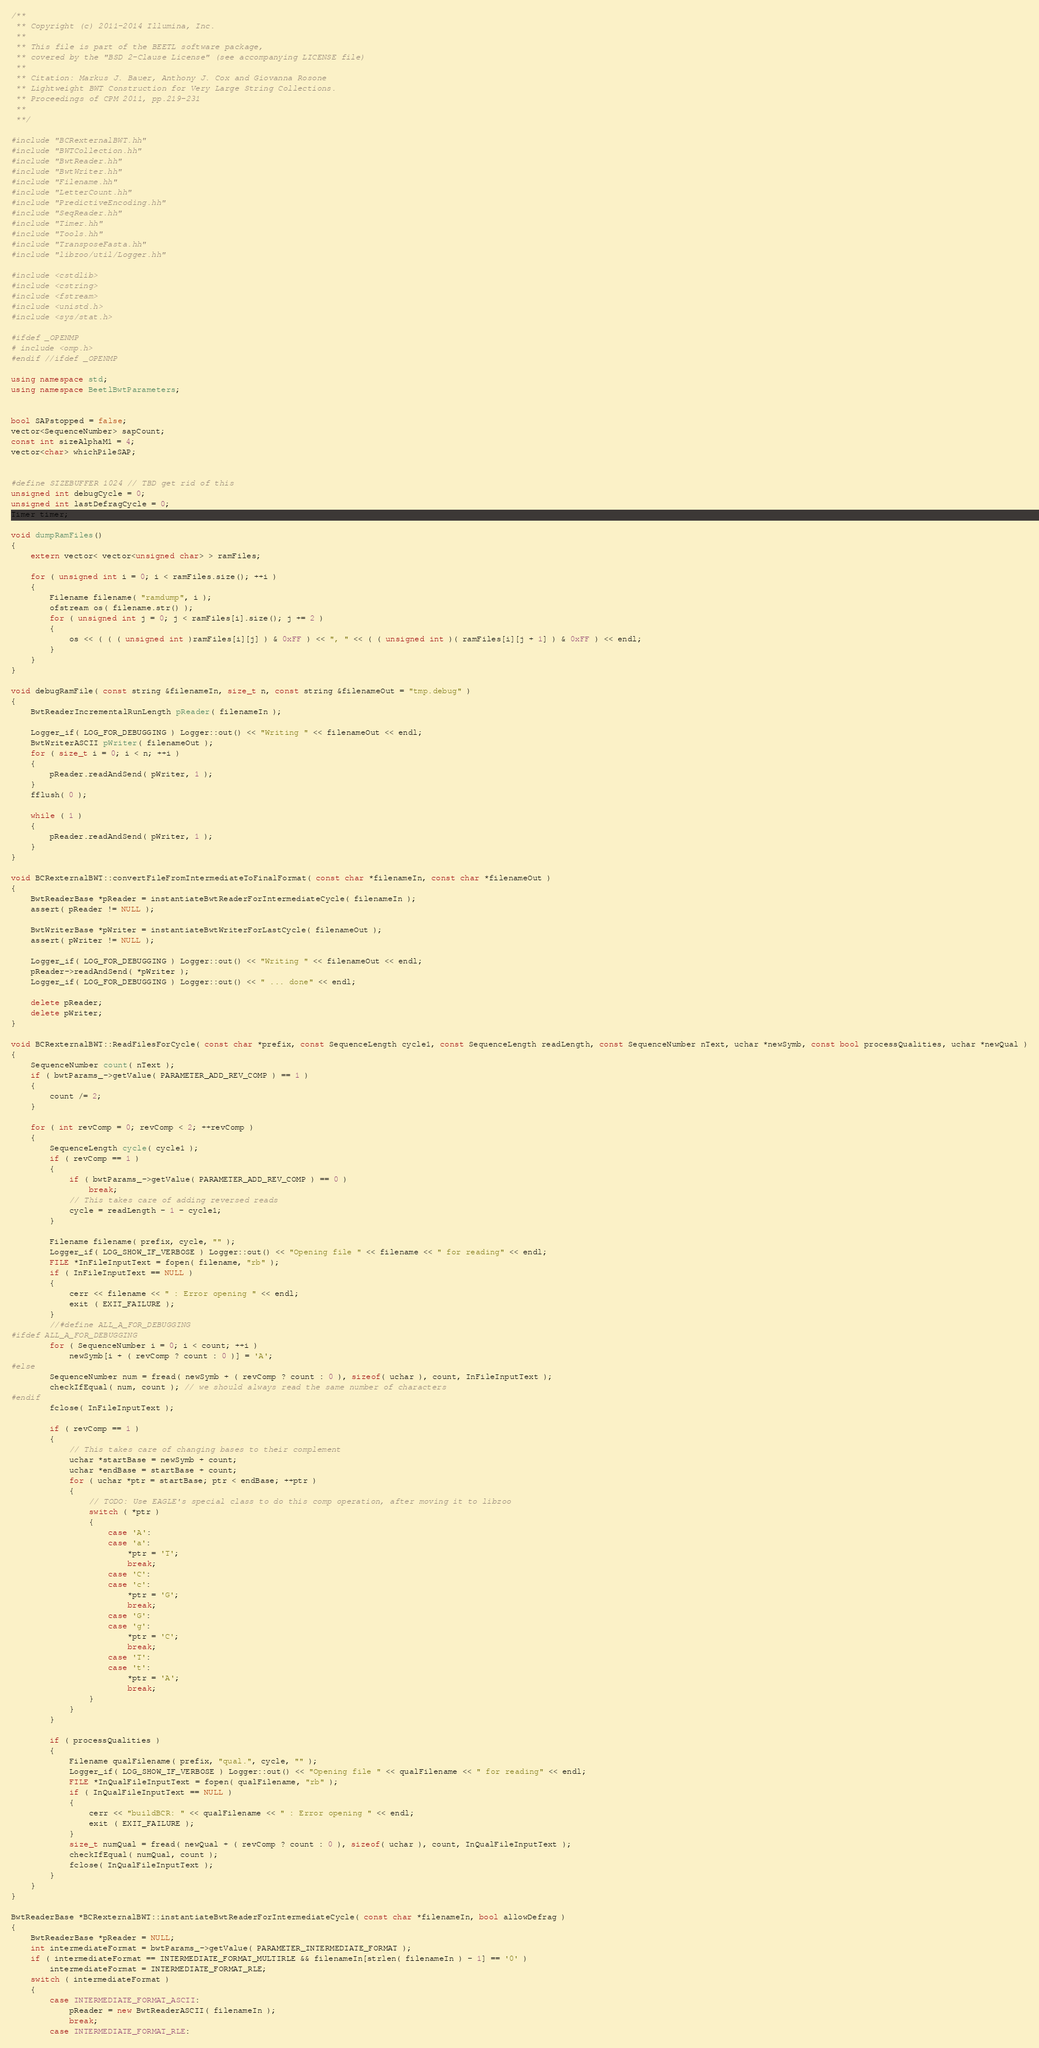Convert code to text. <code><loc_0><loc_0><loc_500><loc_500><_C++_>/**
 ** Copyright (c) 2011-2014 Illumina, Inc.
 **
 ** This file is part of the BEETL software package,
 ** covered by the "BSD 2-Clause License" (see accompanying LICENSE file)
 **
 ** Citation: Markus J. Bauer, Anthony J. Cox and Giovanna Rosone
 ** Lightweight BWT Construction for Very Large String Collections.
 ** Proceedings of CPM 2011, pp.219-231
 **
 **/

#include "BCRexternalBWT.hh"
#include "BWTCollection.hh"
#include "BwtReader.hh"
#include "BwtWriter.hh"
#include "Filename.hh"
#include "LetterCount.hh"
#include "PredictiveEncoding.hh"
#include "SeqReader.hh"
#include "Timer.hh"
#include "Tools.hh"
#include "TransposeFasta.hh"
#include "libzoo/util/Logger.hh"

#include <cstdlib>
#include <cstring>
#include <fstream>
#include <unistd.h>
#include <sys/stat.h>

#ifdef _OPENMP
# include <omp.h>
#endif //ifdef _OPENMP

using namespace std;
using namespace BeetlBwtParameters;


bool SAPstopped = false;
vector<SequenceNumber> sapCount;
const int sizeAlphaM1 = 4;
vector<char> whichPileSAP;


#define SIZEBUFFER 1024 // TBD get rid of this
unsigned int debugCycle = 0;
unsigned int lastDefragCycle = 0;
Timer timer;

void dumpRamFiles()
{
    extern vector< vector<unsigned char> > ramFiles;

    for ( unsigned int i = 0; i < ramFiles.size(); ++i )
    {
        Filename filename( "ramdump", i );
        ofstream os( filename.str() );
        for ( unsigned int j = 0; j < ramFiles[i].size(); j += 2 )
        {
            os << ( ( ( unsigned int )ramFiles[i][j] ) & 0xFF ) << ", " << ( ( unsigned int )( ramFiles[i][j + 1] ) & 0xFF ) << endl;
        }
    }
}

void debugRamFile( const string &filenameIn, size_t n, const string &filenameOut = "tmp.debug" )
{
    BwtReaderIncrementalRunLength pReader( filenameIn );

    Logger_if( LOG_FOR_DEBUGGING ) Logger::out() << "Writing " << filenameOut << endl;
    BwtWriterASCII pWriter( filenameOut );
    for ( size_t i = 0; i < n; ++i )
    {
        pReader.readAndSend( pWriter, 1 );
    }
    fflush( 0 );

    while ( 1 )
    {
        pReader.readAndSend( pWriter, 1 );
    }
}

void BCRexternalBWT::convertFileFromIntermediateToFinalFormat( const char *filenameIn, const char *filenameOut )
{
    BwtReaderBase *pReader = instantiateBwtReaderForIntermediateCycle( filenameIn );
    assert( pReader != NULL );

    BwtWriterBase *pWriter = instantiateBwtWriterForLastCycle( filenameOut );
    assert( pWriter != NULL );

    Logger_if( LOG_FOR_DEBUGGING ) Logger::out() << "Writing " << filenameOut << endl;
    pReader->readAndSend( *pWriter );
    Logger_if( LOG_FOR_DEBUGGING ) Logger::out() << " ... done" << endl;

    delete pReader;
    delete pWriter;
}

void BCRexternalBWT::ReadFilesForCycle( const char *prefix, const SequenceLength cycle1, const SequenceLength readLength, const SequenceNumber nText, uchar *newSymb, const bool processQualities, uchar *newQual )
{
    SequenceNumber count( nText );
    if ( bwtParams_->getValue( PARAMETER_ADD_REV_COMP ) == 1 )
    {
        count /= 2;
    }

    for ( int revComp = 0; revComp < 2; ++revComp )
    {
        SequenceLength cycle( cycle1 );
        if ( revComp == 1 )
        {
            if ( bwtParams_->getValue( PARAMETER_ADD_REV_COMP ) == 0 )
                break;
            // This takes care of adding reversed reads
            cycle = readLength - 1 - cycle1;
        }

        Filename filename( prefix, cycle, "" );
        Logger_if( LOG_SHOW_IF_VERBOSE ) Logger::out() << "Opening file " << filename << " for reading" << endl;
        FILE *InFileInputText = fopen( filename, "rb" );
        if ( InFileInputText == NULL )
        {
            cerr << filename << " : Error opening " << endl;
            exit ( EXIT_FAILURE );
        }
        //#define ALL_A_FOR_DEBUGGING
#ifdef ALL_A_FOR_DEBUGGING
        for ( SequenceNumber i = 0; i < count; ++i )
            newSymb[i + ( revComp ? count : 0 )] = 'A';
#else
        SequenceNumber num = fread( newSymb + ( revComp ? count : 0 ), sizeof( uchar ), count, InFileInputText );
        checkIfEqual( num, count ); // we should always read the same number of characters
#endif
        fclose( InFileInputText );

        if ( revComp == 1 )
        {
            // This takes care of changing bases to their complement
            uchar *startBase = newSymb + count;
            uchar *endBase = startBase + count;
            for ( uchar *ptr = startBase; ptr < endBase; ++ptr )
            {
                // TODO: Use EAGLE's special class to do this comp operation, after moving it to libzoo
                switch ( *ptr )
                {
                    case 'A':
                    case 'a':
                        *ptr = 'T';
                        break;
                    case 'C':
                    case 'c':
                        *ptr = 'G';
                        break;
                    case 'G':
                    case 'g':
                        *ptr = 'C';
                        break;
                    case 'T':
                    case 't':
                        *ptr = 'A';
                        break;
                }
            }
        }

        if ( processQualities )
        {
            Filename qualFilename( prefix, "qual.", cycle, "" );
            Logger_if( LOG_SHOW_IF_VERBOSE ) Logger::out() << "Opening file " << qualFilename << " for reading" << endl;
            FILE *InQualFileInputText = fopen( qualFilename, "rb" );
            if ( InQualFileInputText == NULL )
            {
                cerr << "buildBCR: " << qualFilename << " : Error opening " << endl;
                exit ( EXIT_FAILURE );
            }
            size_t numQual = fread( newQual + ( revComp ? count : 0 ), sizeof( uchar ), count, InQualFileInputText );
            checkIfEqual( numQual, count );
            fclose( InQualFileInputText );
        }
    }
}

BwtReaderBase *BCRexternalBWT::instantiateBwtReaderForIntermediateCycle( const char *filenameIn, bool allowDefrag )
{
    BwtReaderBase *pReader = NULL;
    int intermediateFormat = bwtParams_->getValue( PARAMETER_INTERMEDIATE_FORMAT );
    if ( intermediateFormat == INTERMEDIATE_FORMAT_MULTIRLE && filenameIn[strlen( filenameIn ) - 1] == '0' )
        intermediateFormat = INTERMEDIATE_FORMAT_RLE;
    switch ( intermediateFormat )
    {
        case INTERMEDIATE_FORMAT_ASCII:
            pReader = new BwtReaderASCII( filenameIn );
            break;
        case INTERMEDIATE_FORMAT_RLE:</code> 